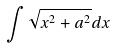<formula> <loc_0><loc_0><loc_500><loc_500>\int \sqrt { x ^ { 2 } + a ^ { 2 } } d x</formula> 